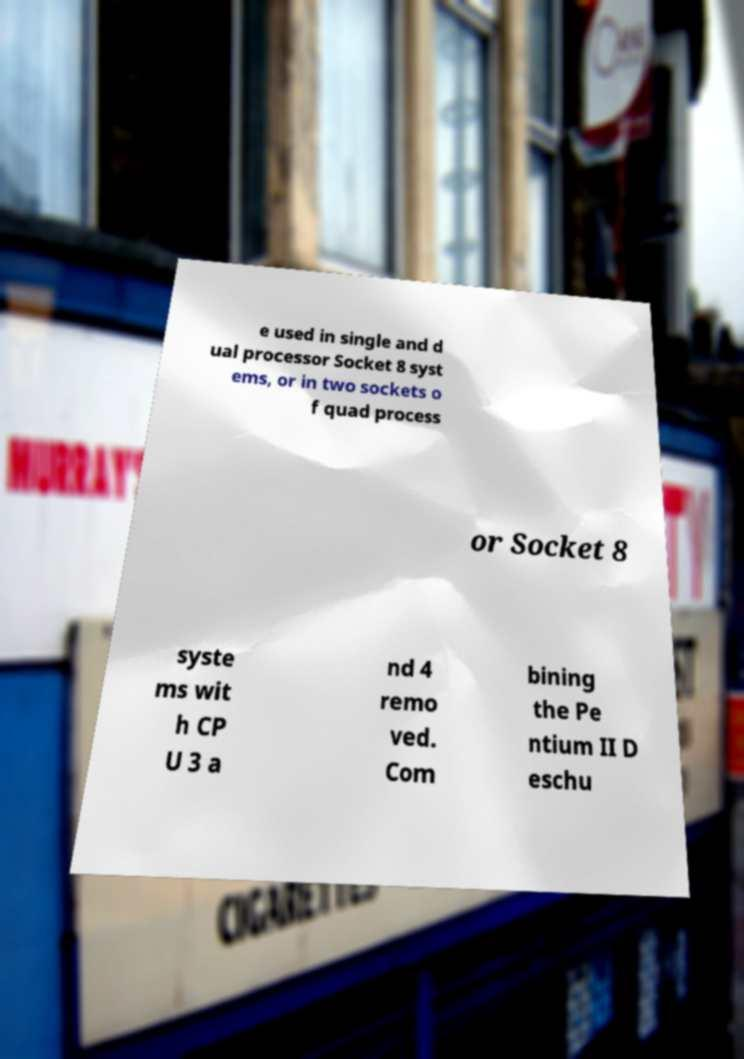Can you accurately transcribe the text from the provided image for me? e used in single and d ual processor Socket 8 syst ems, or in two sockets o f quad process or Socket 8 syste ms wit h CP U 3 a nd 4 remo ved. Com bining the Pe ntium II D eschu 